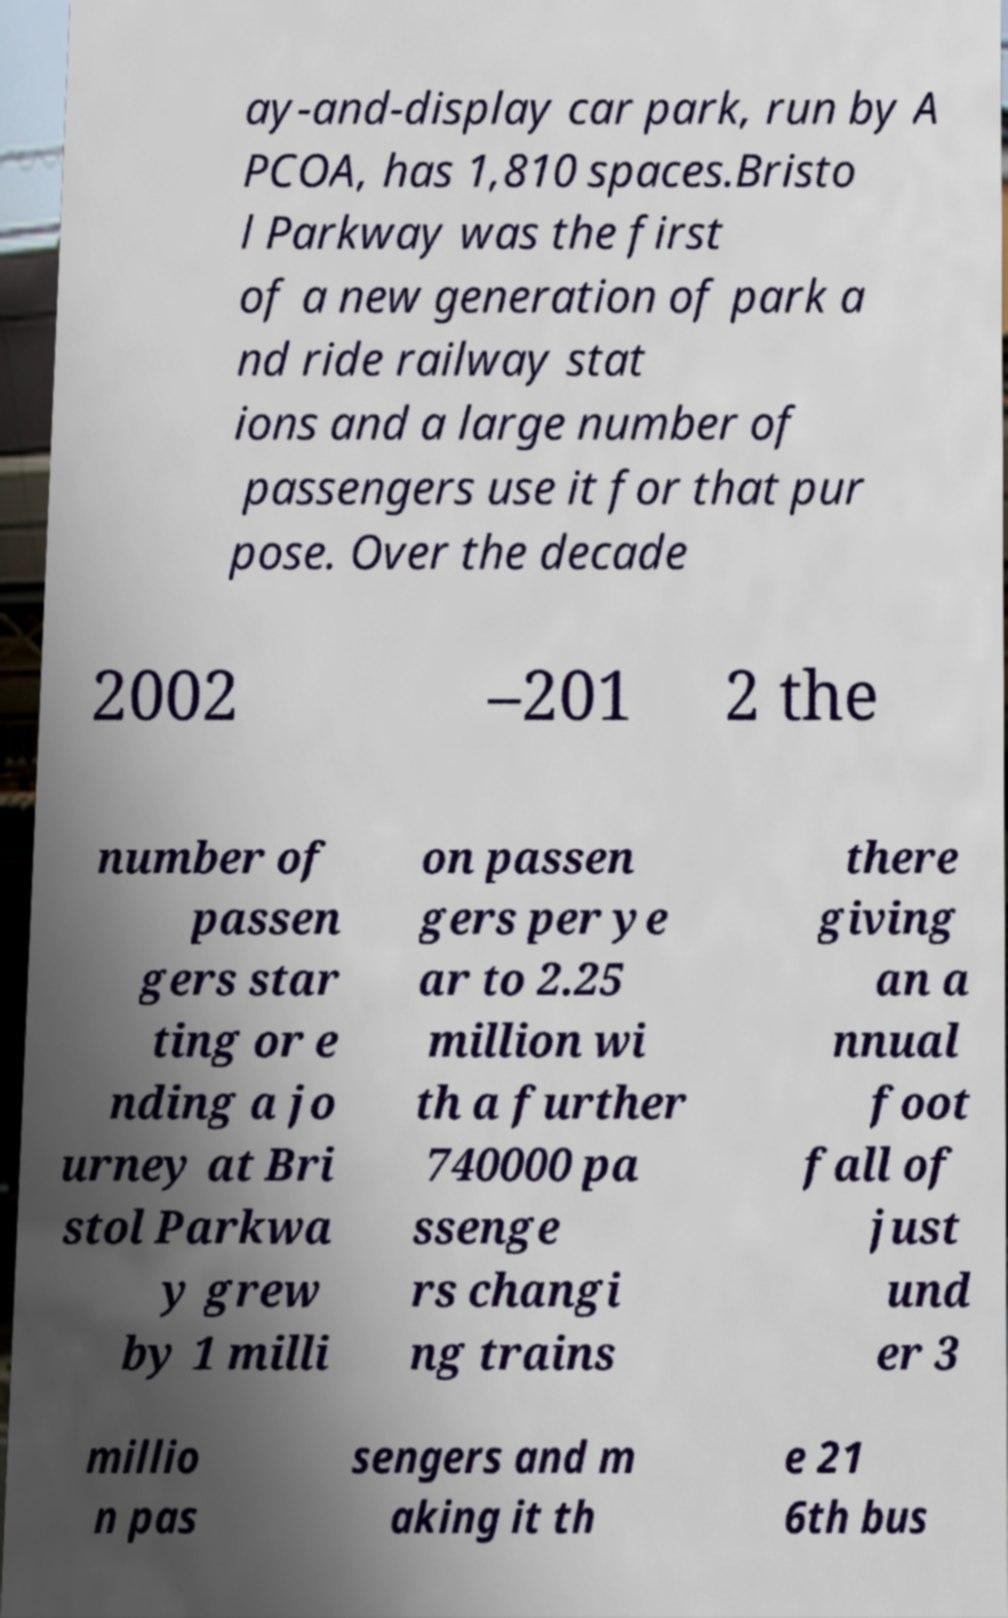Could you extract and type out the text from this image? ay-and-display car park, run by A PCOA, has 1,810 spaces.Bristo l Parkway was the first of a new generation of park a nd ride railway stat ions and a large number of passengers use it for that pur pose. Over the decade 2002 –201 2 the number of passen gers star ting or e nding a jo urney at Bri stol Parkwa y grew by 1 milli on passen gers per ye ar to 2.25 million wi th a further 740000 pa ssenge rs changi ng trains there giving an a nnual foot fall of just und er 3 millio n pas sengers and m aking it th e 21 6th bus 